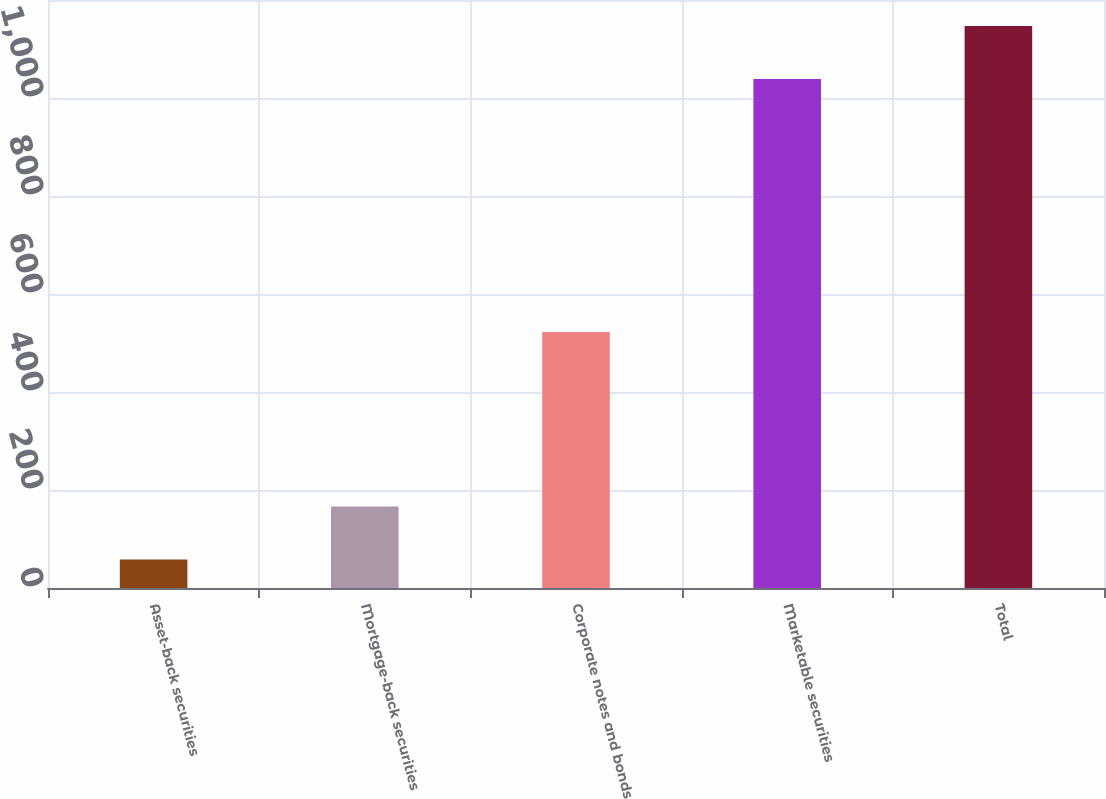Convert chart. <chart><loc_0><loc_0><loc_500><loc_500><bar_chart><fcel>Asset-back securities<fcel>Mortgage-back securities<fcel>Corporate notes and bonds<fcel>Marketable securities<fcel>Total<nl><fcel>58<fcel>166.29<fcel>522.6<fcel>1038.7<fcel>1146.99<nl></chart> 